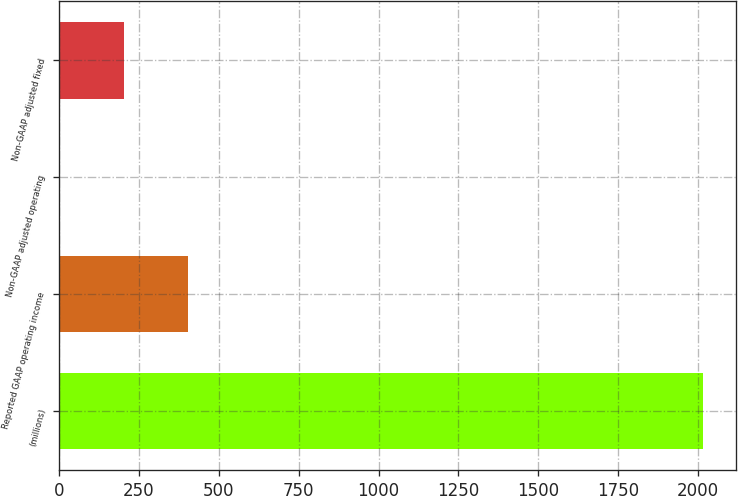Convert chart. <chart><loc_0><loc_0><loc_500><loc_500><bar_chart><fcel>(millions)<fcel>Reported GAAP operating income<fcel>Non-GAAP adjusted operating<fcel>Non-GAAP adjusted fixed<nl><fcel>2016<fcel>404.8<fcel>2<fcel>203.4<nl></chart> 